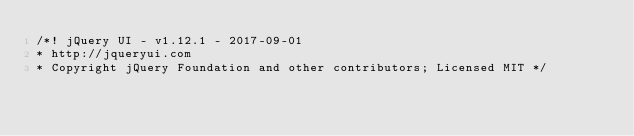<code> <loc_0><loc_0><loc_500><loc_500><_CSS_>/*! jQuery UI - v1.12.1 - 2017-09-01
* http://jqueryui.com
* Copyright jQuery Foundation and other contributors; Licensed MIT */
</code> 